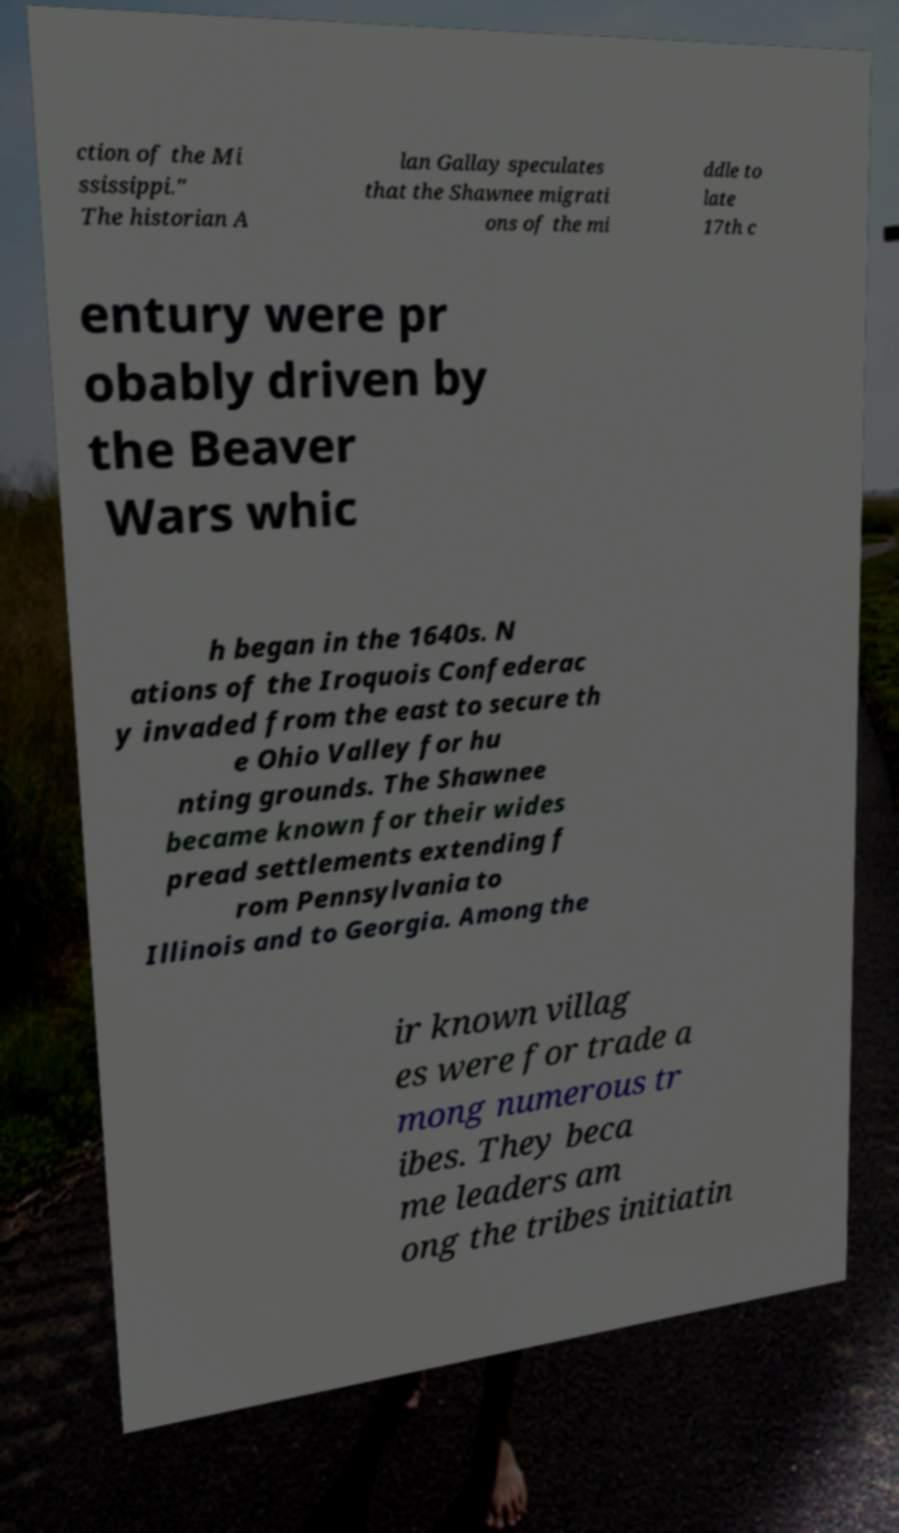Could you extract and type out the text from this image? ction of the Mi ssissippi." The historian A lan Gallay speculates that the Shawnee migrati ons of the mi ddle to late 17th c entury were pr obably driven by the Beaver Wars whic h began in the 1640s. N ations of the Iroquois Confederac y invaded from the east to secure th e Ohio Valley for hu nting grounds. The Shawnee became known for their wides pread settlements extending f rom Pennsylvania to Illinois and to Georgia. Among the ir known villag es were for trade a mong numerous tr ibes. They beca me leaders am ong the tribes initiatin 